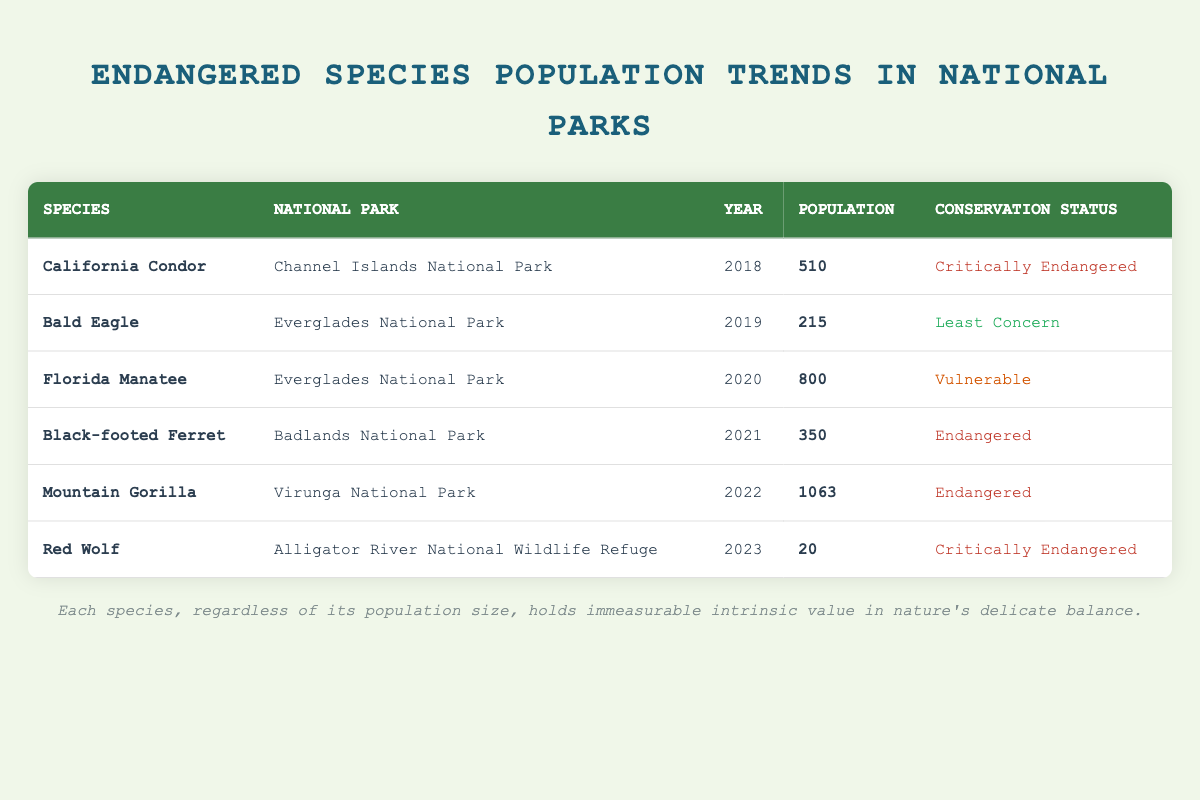What is the population of the California Condor in 2018? The table shows that the California Condor's population in Channel Islands National Park for the year 2018 is listed as 510.
Answer: 510 Which species has the highest population, and what is that population? The table indicates that the Mountain Gorilla has the highest population at 1,063 in Virunga National Park in 2022.
Answer: Mountain Gorilla, 1063 Is the Red Wolf listed as Endangered or Critically Endangered? From the table, it can be seen that the Red Wolf is categorized as Critically Endangered for the year 2023.
Answer: Critically Endangered What is the total population of the Black-footed Ferret and Florida Manatee combined? The population of the Black-footed Ferret is 350 (2021) and the Florida Manatee is 800 (2020). Adding these together gives 350 + 800 = 1150.
Answer: 1150 Are there more species categorized as Endangered or Critically Endangered in this table? The table shows 3 species classified as Endangered (Black-footed Ferret, Mountain Gorilla, Florida Manatee) and 3 species classified as Critically Endangered (California Condor and Red Wolf). Since both counts are equal, the answer is that they are balanced.
Answer: Balanced What year did the Bald Eagle have a population of 215? The table indicates the Bald Eagle was recorded with a population of 215 in the year 2019 in Everglades National Park.
Answer: 2019 Which national park has the lowest population of endangered species listed in this table? The table displays the Red Wolf in Alligator River National Wildlife Refuge with a population of 20, which is the lowest compared to the populations of other listed species.
Answer: Alligator River National Wildlife Refuge What is the conservation status of the Mountain Gorilla? According to the table, the conservation status of the Mountain Gorilla is classified as Endangered for the year 2022.
Answer: Endangered Is the Florida Manatee's conservation status listed as Least Concern? The table categorizes the Florida Manatee as Vulnerable, not Least Concern, which means this statement is false.
Answer: False 